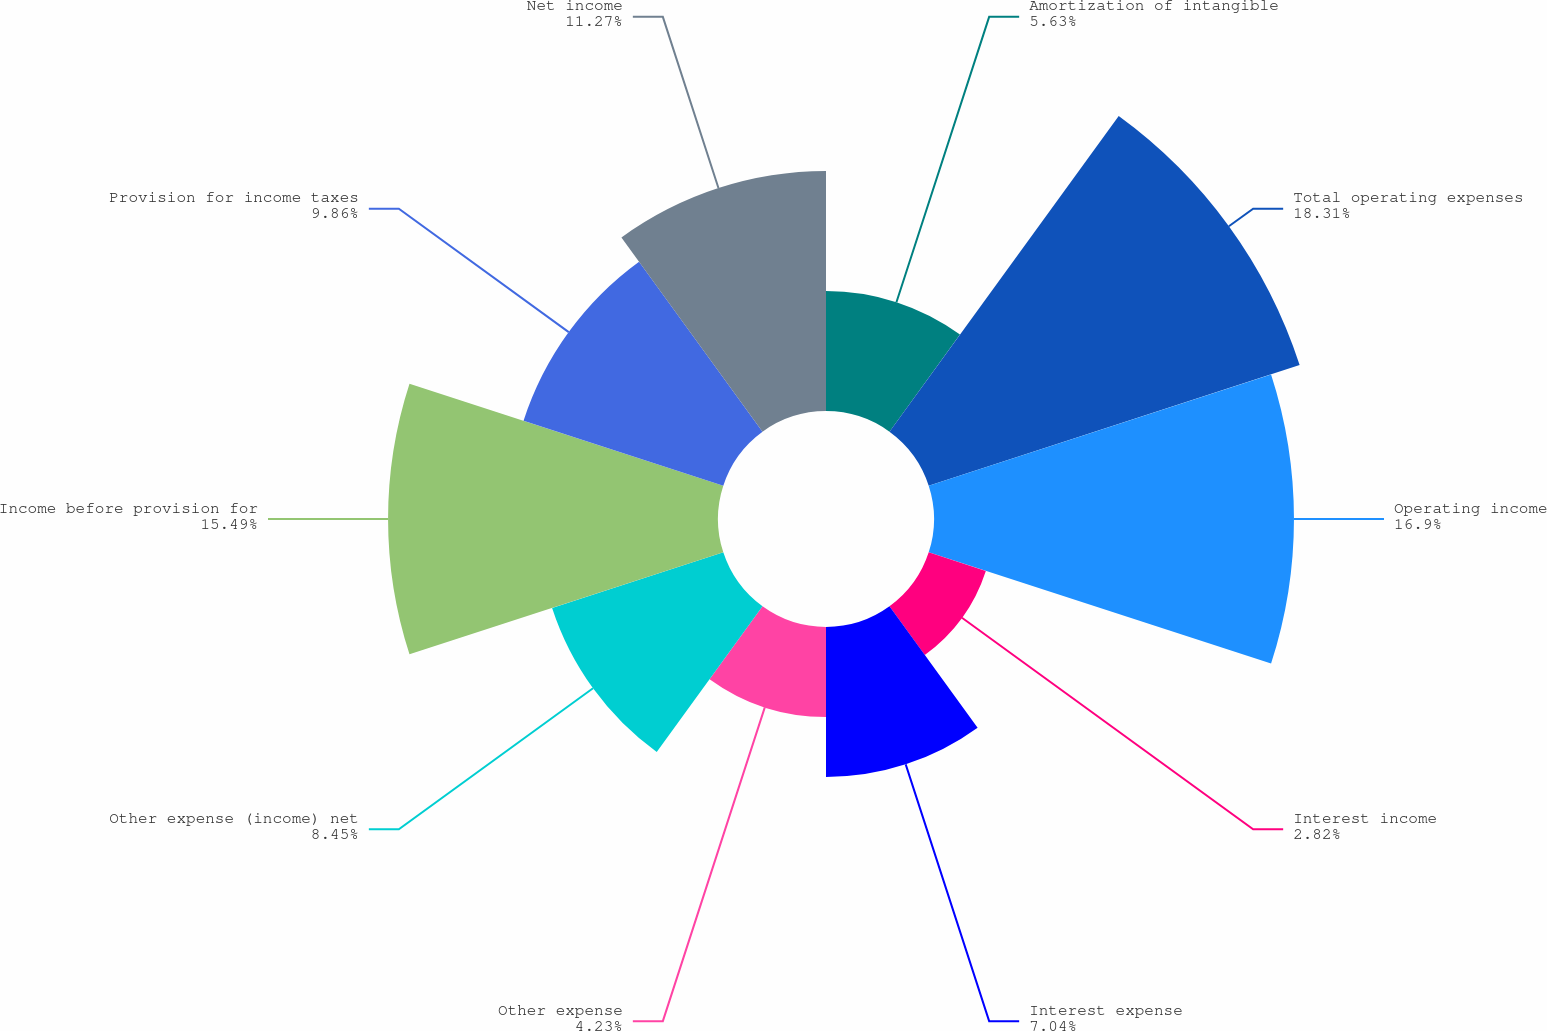Convert chart to OTSL. <chart><loc_0><loc_0><loc_500><loc_500><pie_chart><fcel>Amortization of intangible<fcel>Total operating expenses<fcel>Operating income<fcel>Interest income<fcel>Interest expense<fcel>Other expense<fcel>Other expense (income) net<fcel>Income before provision for<fcel>Provision for income taxes<fcel>Net income<nl><fcel>5.63%<fcel>18.31%<fcel>16.9%<fcel>2.82%<fcel>7.04%<fcel>4.23%<fcel>8.45%<fcel>15.49%<fcel>9.86%<fcel>11.27%<nl></chart> 